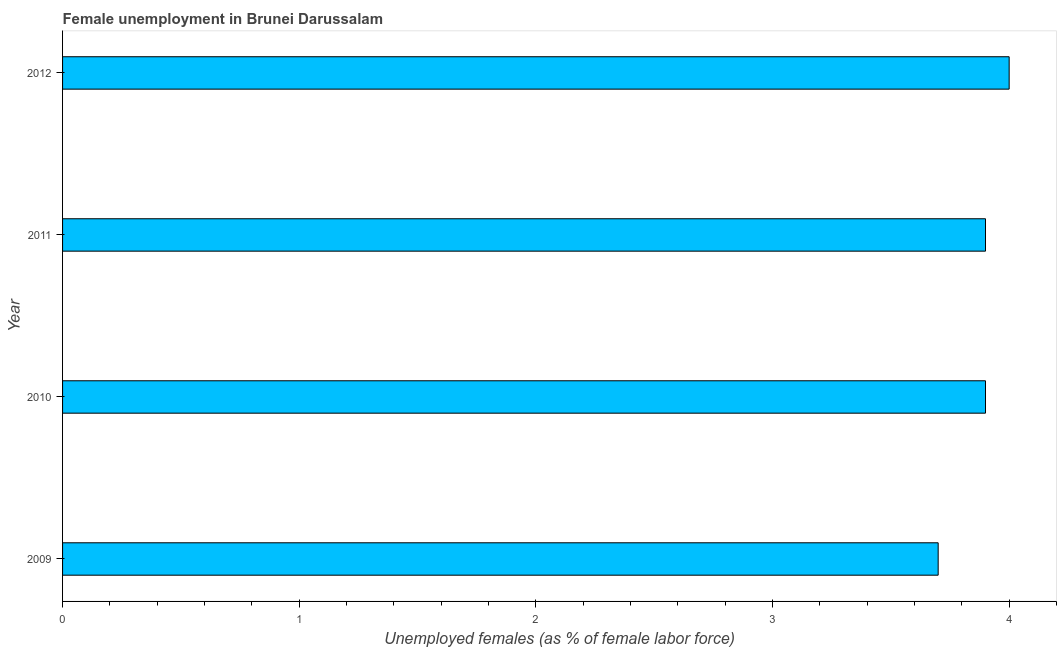Does the graph contain grids?
Give a very brief answer. No. What is the title of the graph?
Your answer should be very brief. Female unemployment in Brunei Darussalam. What is the label or title of the X-axis?
Offer a terse response. Unemployed females (as % of female labor force). What is the label or title of the Y-axis?
Your answer should be compact. Year. What is the unemployed females population in 2011?
Provide a short and direct response. 3.9. Across all years, what is the minimum unemployed females population?
Offer a very short reply. 3.7. In which year was the unemployed females population maximum?
Offer a terse response. 2012. In which year was the unemployed females population minimum?
Keep it short and to the point. 2009. What is the sum of the unemployed females population?
Provide a succinct answer. 15.5. What is the difference between the unemployed females population in 2010 and 2011?
Your answer should be very brief. 0. What is the average unemployed females population per year?
Your response must be concise. 3.88. What is the median unemployed females population?
Offer a terse response. 3.9. In how many years, is the unemployed females population greater than 3.4 %?
Keep it short and to the point. 4. What is the ratio of the unemployed females population in 2009 to that in 2010?
Make the answer very short. 0.95. What is the difference between the highest and the second highest unemployed females population?
Provide a short and direct response. 0.1. In how many years, is the unemployed females population greater than the average unemployed females population taken over all years?
Your answer should be compact. 3. How many bars are there?
Keep it short and to the point. 4. What is the Unemployed females (as % of female labor force) in 2009?
Offer a terse response. 3.7. What is the Unemployed females (as % of female labor force) in 2010?
Your answer should be compact. 3.9. What is the Unemployed females (as % of female labor force) in 2011?
Give a very brief answer. 3.9. What is the Unemployed females (as % of female labor force) of 2012?
Provide a short and direct response. 4. What is the difference between the Unemployed females (as % of female labor force) in 2009 and 2010?
Ensure brevity in your answer.  -0.2. What is the ratio of the Unemployed females (as % of female labor force) in 2009 to that in 2010?
Provide a succinct answer. 0.95. What is the ratio of the Unemployed females (as % of female labor force) in 2009 to that in 2011?
Your response must be concise. 0.95. What is the ratio of the Unemployed females (as % of female labor force) in 2009 to that in 2012?
Provide a short and direct response. 0.93. What is the ratio of the Unemployed females (as % of female labor force) in 2010 to that in 2011?
Ensure brevity in your answer.  1. What is the ratio of the Unemployed females (as % of female labor force) in 2010 to that in 2012?
Ensure brevity in your answer.  0.97. 